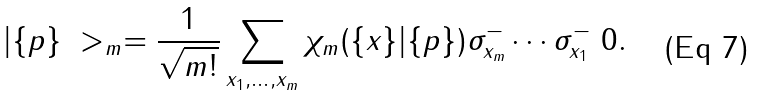<formula> <loc_0><loc_0><loc_500><loc_500>| \{ p \} \ > _ { m } = \frac { 1 } { \sqrt { m ! } } \sum _ { x _ { 1 } , \dots , x _ { m } } \chi _ { m } ( \{ x \} | \{ p \} ) \sigma _ { x _ { m } } ^ { - } \cdots \sigma _ { x _ { 1 } } ^ { - } \ 0 .</formula> 